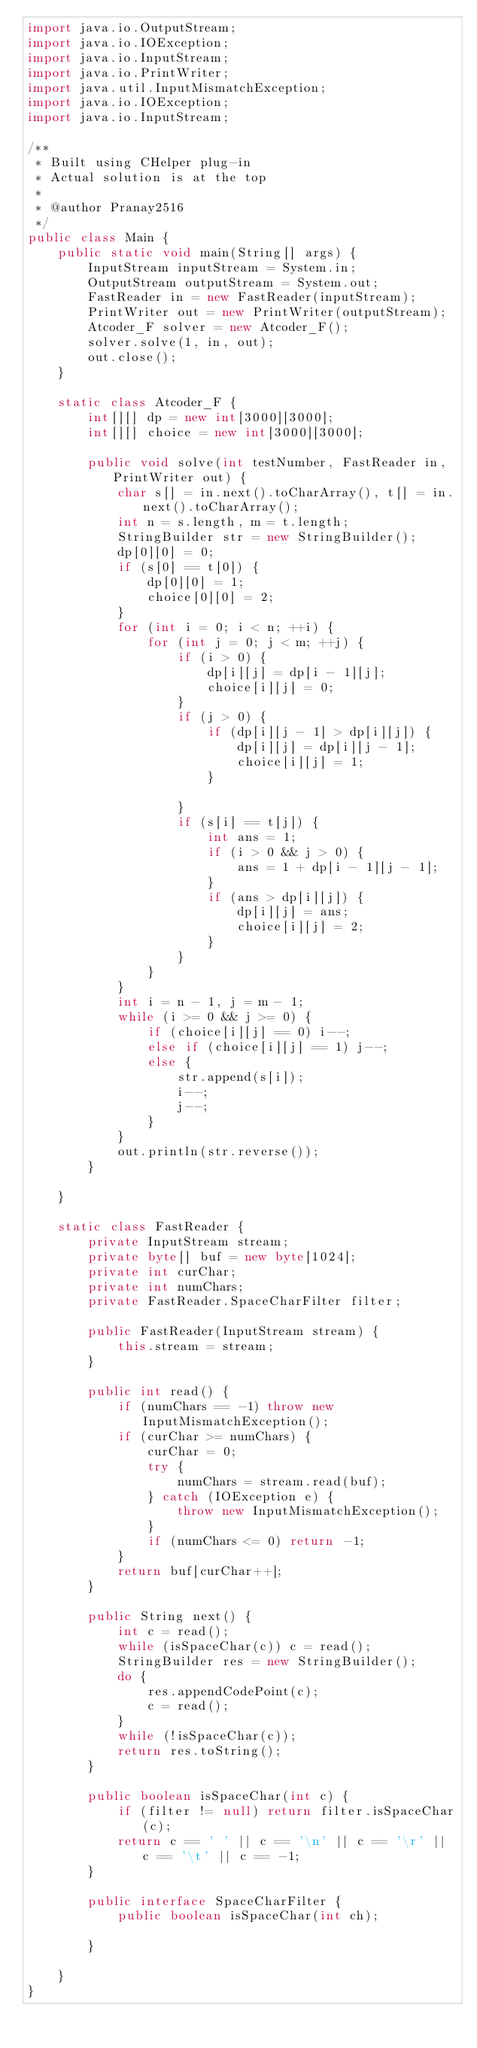Convert code to text. <code><loc_0><loc_0><loc_500><loc_500><_Java_>import java.io.OutputStream;
import java.io.IOException;
import java.io.InputStream;
import java.io.PrintWriter;
import java.util.InputMismatchException;
import java.io.IOException;
import java.io.InputStream;

/**
 * Built using CHelper plug-in
 * Actual solution is at the top
 *
 * @author Pranay2516
 */
public class Main {
    public static void main(String[] args) {
        InputStream inputStream = System.in;
        OutputStream outputStream = System.out;
        FastReader in = new FastReader(inputStream);
        PrintWriter out = new PrintWriter(outputStream);
        Atcoder_F solver = new Atcoder_F();
        solver.solve(1, in, out);
        out.close();
    }

    static class Atcoder_F {
        int[][] dp = new int[3000][3000];
        int[][] choice = new int[3000][3000];

        public void solve(int testNumber, FastReader in, PrintWriter out) {
            char s[] = in.next().toCharArray(), t[] = in.next().toCharArray();
            int n = s.length, m = t.length;
            StringBuilder str = new StringBuilder();
            dp[0][0] = 0;
            if (s[0] == t[0]) {
                dp[0][0] = 1;
                choice[0][0] = 2;
            }
            for (int i = 0; i < n; ++i) {
                for (int j = 0; j < m; ++j) {
                    if (i > 0) {
                        dp[i][j] = dp[i - 1][j];
                        choice[i][j] = 0;
                    }
                    if (j > 0) {
                        if (dp[i][j - 1] > dp[i][j]) {
                            dp[i][j] = dp[i][j - 1];
                            choice[i][j] = 1;
                        }

                    }
                    if (s[i] == t[j]) {
                        int ans = 1;
                        if (i > 0 && j > 0) {
                            ans = 1 + dp[i - 1][j - 1];
                        }
                        if (ans > dp[i][j]) {
                            dp[i][j] = ans;
                            choice[i][j] = 2;
                        }
                    }
                }
            }
            int i = n - 1, j = m - 1;
            while (i >= 0 && j >= 0) {
                if (choice[i][j] == 0) i--;
                else if (choice[i][j] == 1) j--;
                else {
                    str.append(s[i]);
                    i--;
                    j--;
                }
            }
            out.println(str.reverse());
        }

    }

    static class FastReader {
        private InputStream stream;
        private byte[] buf = new byte[1024];
        private int curChar;
        private int numChars;
        private FastReader.SpaceCharFilter filter;

        public FastReader(InputStream stream) {
            this.stream = stream;
        }

        public int read() {
            if (numChars == -1) throw new InputMismatchException();
            if (curChar >= numChars) {
                curChar = 0;
                try {
                    numChars = stream.read(buf);
                } catch (IOException e) {
                    throw new InputMismatchException();
                }
                if (numChars <= 0) return -1;
            }
            return buf[curChar++];
        }

        public String next() {
            int c = read();
            while (isSpaceChar(c)) c = read();
            StringBuilder res = new StringBuilder();
            do {
                res.appendCodePoint(c);
                c = read();
            }
            while (!isSpaceChar(c));
            return res.toString();
        }

        public boolean isSpaceChar(int c) {
            if (filter != null) return filter.isSpaceChar(c);
            return c == ' ' || c == '\n' || c == '\r' || c == '\t' || c == -1;
        }

        public interface SpaceCharFilter {
            public boolean isSpaceChar(int ch);

        }

    }
}

</code> 